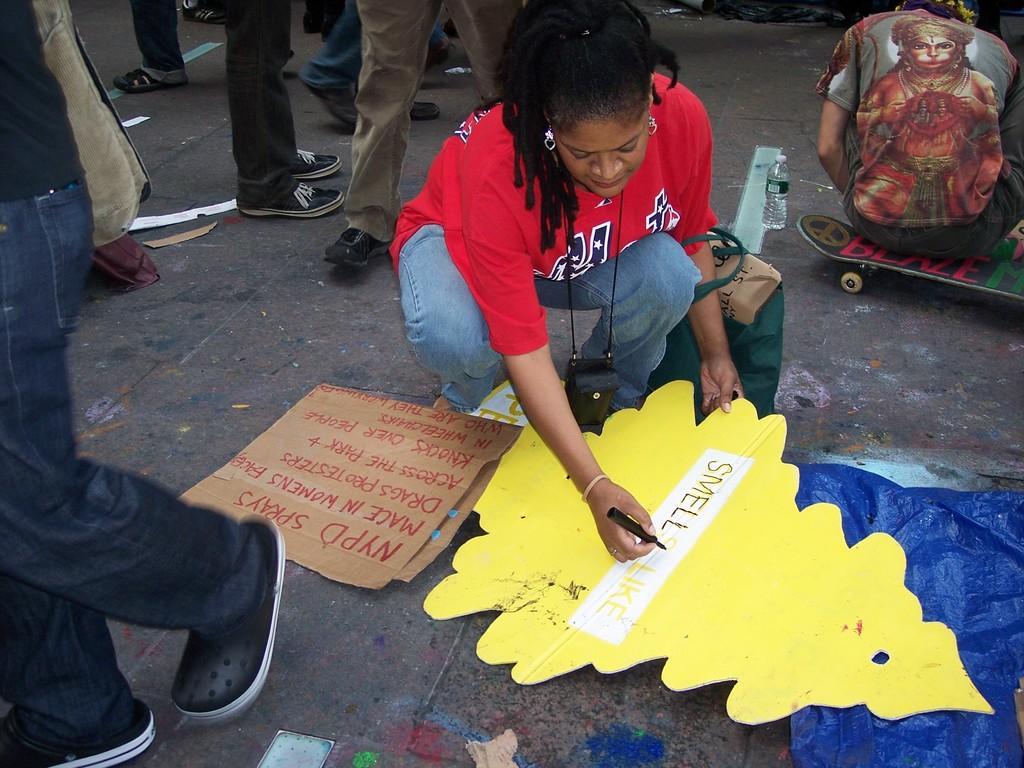Could you give a brief overview of what you see in this image? In this image we can see persons standing on the road and one of them is sitting and drawing something on the cardboards. In the background we can see persons sitting on the skateboard, plastic bottle, bag and some text written on the board. 